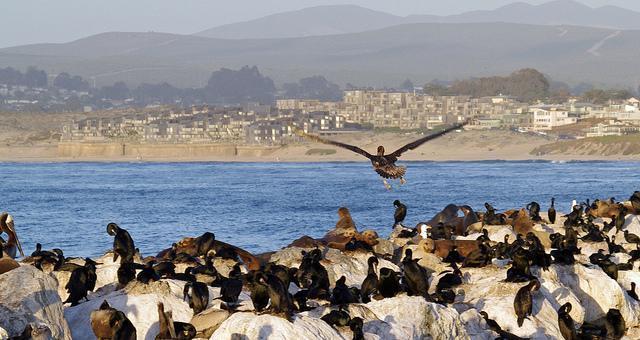How many birds are flying?
Give a very brief answer. 1. How many elephants in the scene?
Give a very brief answer. 0. 